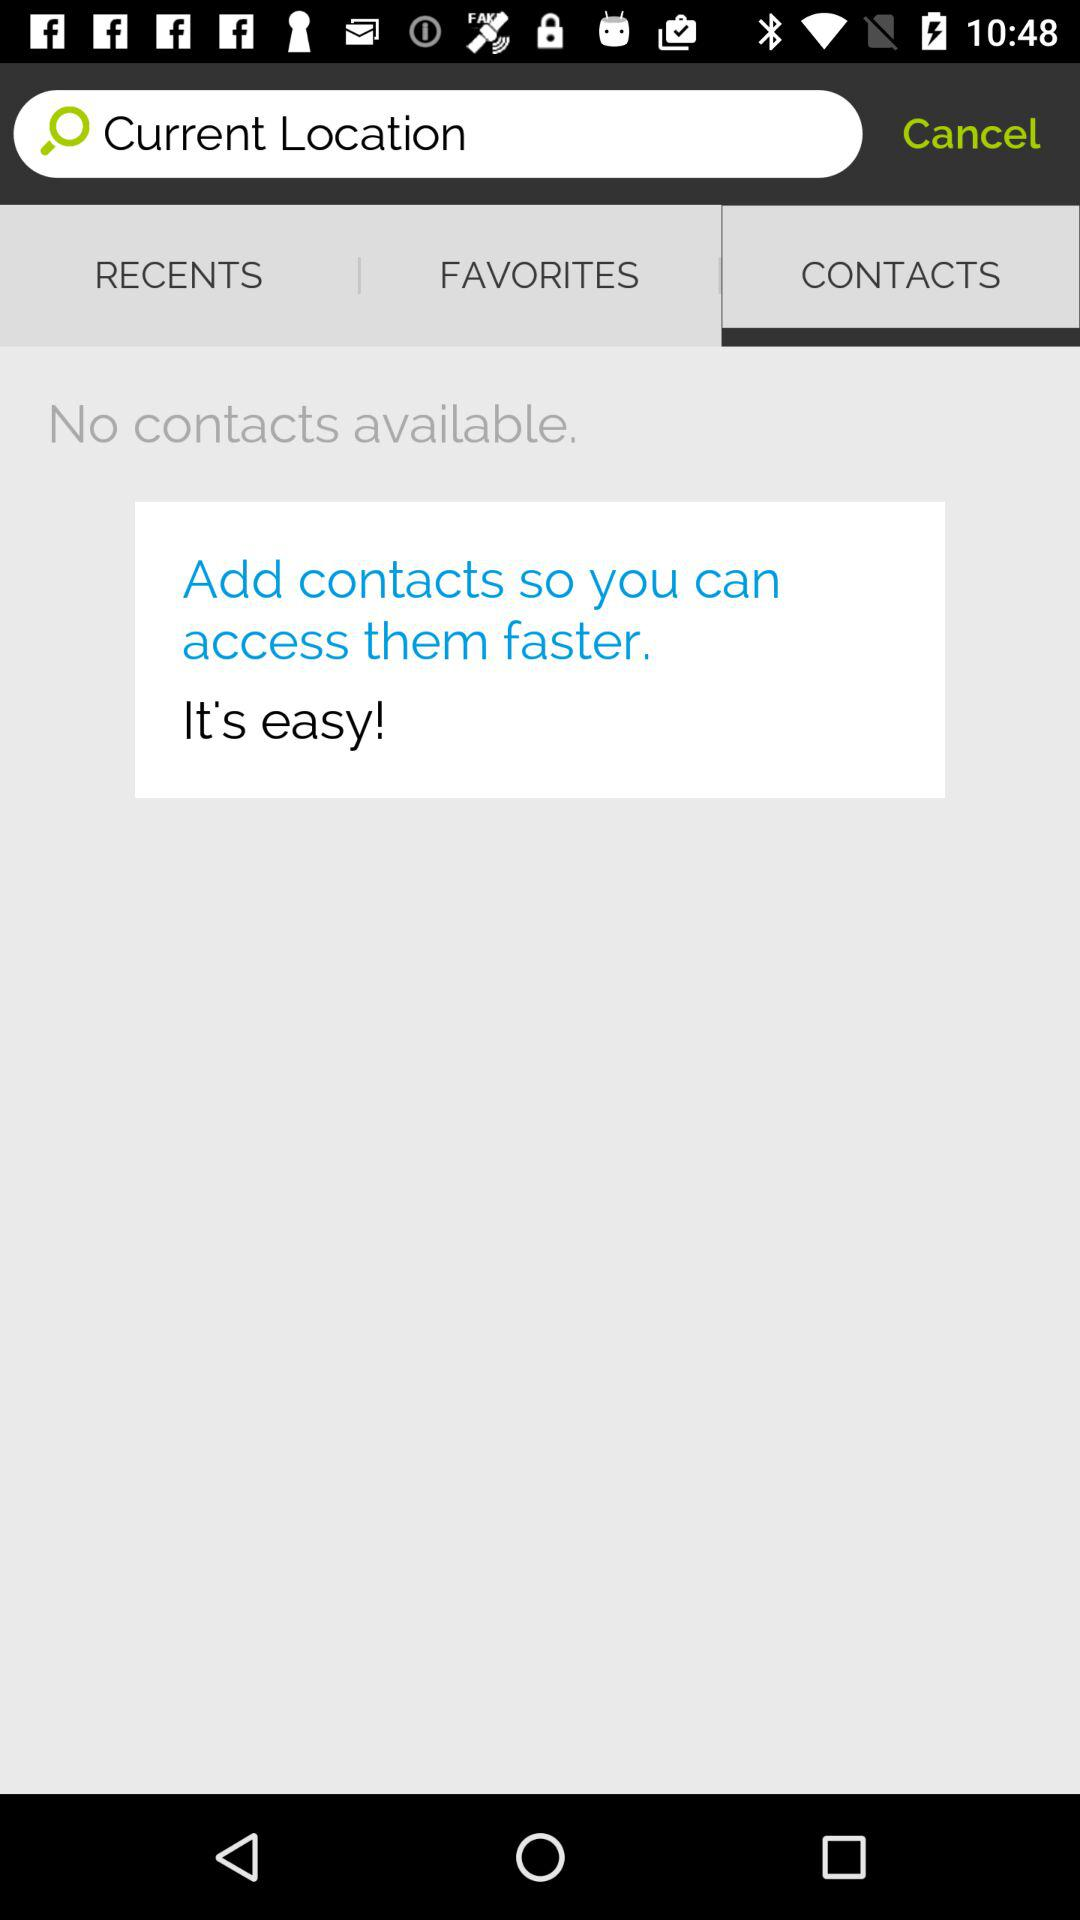Which tab is open? The open tab is "CONTACTS". 